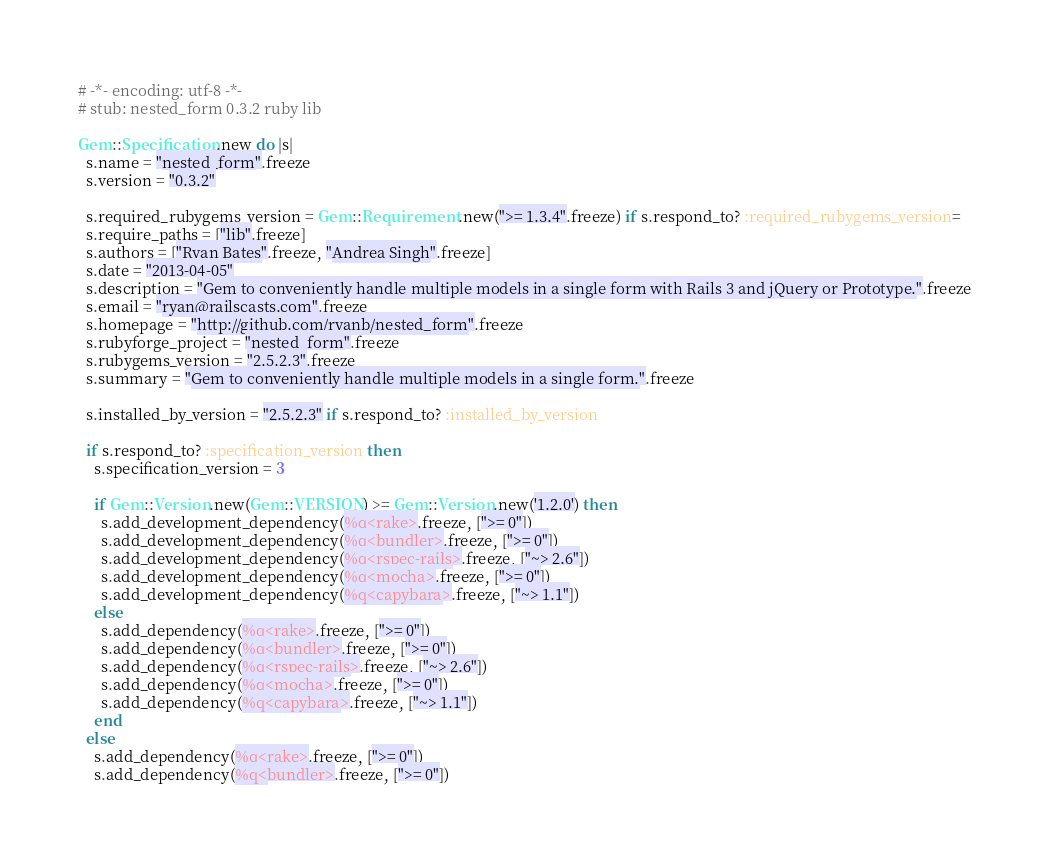<code> <loc_0><loc_0><loc_500><loc_500><_Ruby_># -*- encoding: utf-8 -*-
# stub: nested_form 0.3.2 ruby lib

Gem::Specification.new do |s|
  s.name = "nested_form".freeze
  s.version = "0.3.2"

  s.required_rubygems_version = Gem::Requirement.new(">= 1.3.4".freeze) if s.respond_to? :required_rubygems_version=
  s.require_paths = ["lib".freeze]
  s.authors = ["Ryan Bates".freeze, "Andrea Singh".freeze]
  s.date = "2013-04-05"
  s.description = "Gem to conveniently handle multiple models in a single form with Rails 3 and jQuery or Prototype.".freeze
  s.email = "ryan@railscasts.com".freeze
  s.homepage = "http://github.com/ryanb/nested_form".freeze
  s.rubyforge_project = "nested_form".freeze
  s.rubygems_version = "2.5.2.3".freeze
  s.summary = "Gem to conveniently handle multiple models in a single form.".freeze

  s.installed_by_version = "2.5.2.3" if s.respond_to? :installed_by_version

  if s.respond_to? :specification_version then
    s.specification_version = 3

    if Gem::Version.new(Gem::VERSION) >= Gem::Version.new('1.2.0') then
      s.add_development_dependency(%q<rake>.freeze, [">= 0"])
      s.add_development_dependency(%q<bundler>.freeze, [">= 0"])
      s.add_development_dependency(%q<rspec-rails>.freeze, ["~> 2.6"])
      s.add_development_dependency(%q<mocha>.freeze, [">= 0"])
      s.add_development_dependency(%q<capybara>.freeze, ["~> 1.1"])
    else
      s.add_dependency(%q<rake>.freeze, [">= 0"])
      s.add_dependency(%q<bundler>.freeze, [">= 0"])
      s.add_dependency(%q<rspec-rails>.freeze, ["~> 2.6"])
      s.add_dependency(%q<mocha>.freeze, [">= 0"])
      s.add_dependency(%q<capybara>.freeze, ["~> 1.1"])
    end
  else
    s.add_dependency(%q<rake>.freeze, [">= 0"])
    s.add_dependency(%q<bundler>.freeze, [">= 0"])</code> 